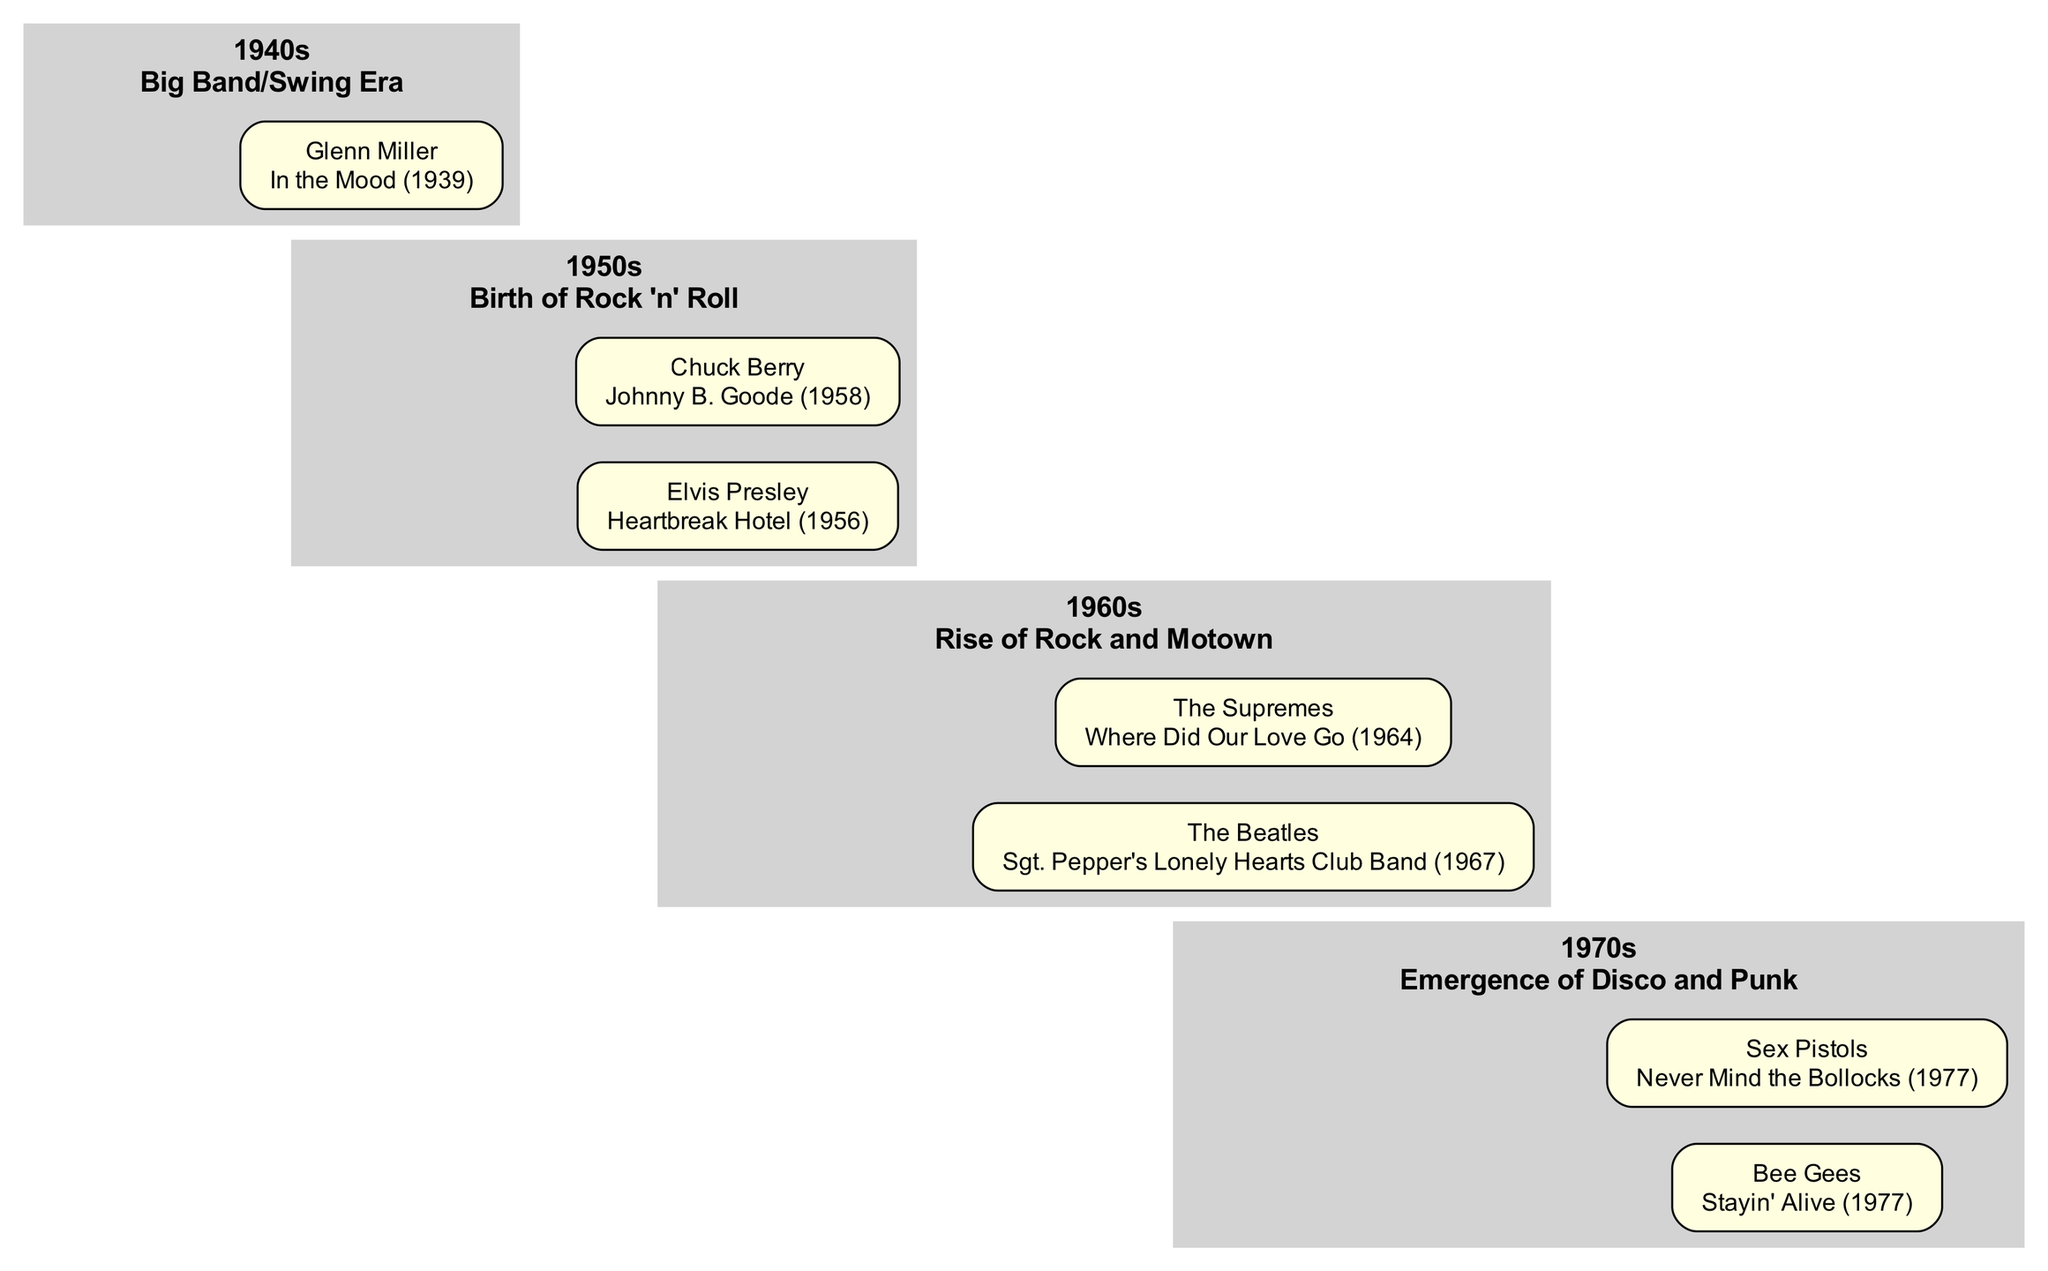What genre is represented in the 1950s node? The 1950s node is labeled "Birth of Rock 'n' Roll," which indicates that the major genre of that decade is Rock 'n' Roll.
Answer: Birth of Rock 'n' Roll Who is the influential artist associated with the 1960s? The 1960s node contains edges connecting to The Beatles and The Supremes, both of which are labeled as influential artists for this decade. Choosing one, The Beatles is an important figure in this time.
Answer: The Beatles How many influential artists are listed for the 1970s? The 1970s node has edges leading to two artists, Bee Gees and Sex Pistols, indicating that there are two influential artists associated with this decade.
Answer: 2 Which album is associated with Elvis Presley? The edge from the 1950s node to Elvis Presley references his well-known song "Heartbreak Hotel," which is an important piece from that period.
Answer: Heartbreak Hotel What decade encompasses the song "Sgt. Pepper's Lonely Hearts Club Band"? The song "Sgt. Pepper's Lonely Hearts Club Band" is connected to The Beatles, who are associated with the 1960s node in the diagram, placing it in that decade.
Answer: 1960s Which genre emerged in the 1970s according to the diagram? The 1970s node describes the "Emergence of Disco and Punk," indicating that these genres became prominent during this decade.
Answer: Disco and Punk How many total nodes (including decades and artists) are in the diagram? There are four decade nodes and six artist nodes, totalling ten nodes overall in the diagram. Adding the decade and artist nodes results in ten.
Answer: 10 What is the primary connection type shown between decades and artists? The diagram indicates that the primary connection type between the decades and artists is labeled "influential artist," establishing a clear relationship of influence.
Answer: influential artist Which artist is connected to the 1940s node? The 1940s node connects to Glenn Miller, who is noted as the influential artist associated with this decade in the diagram.
Answer: Glenn Miller 